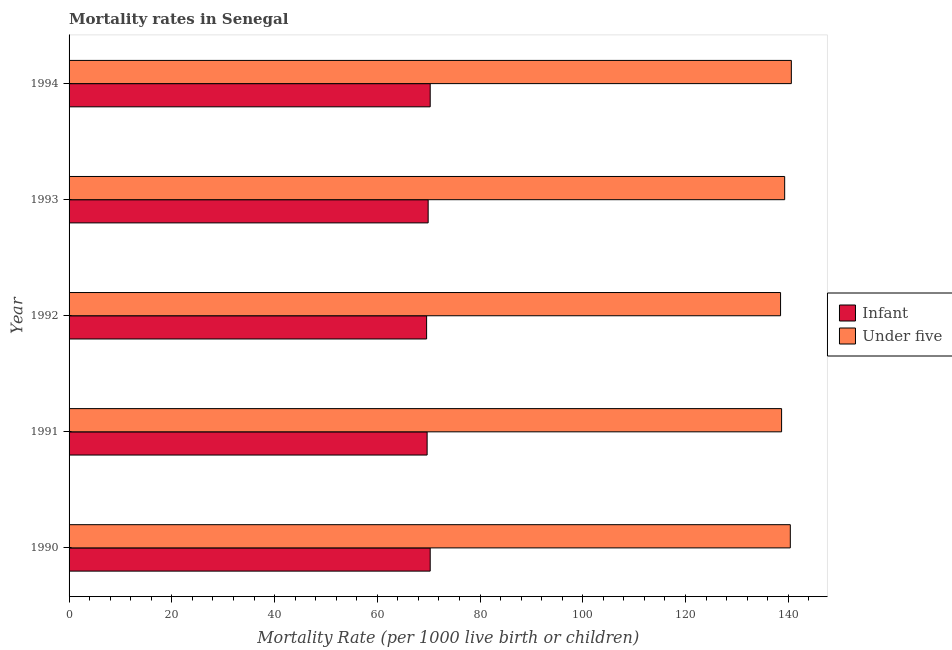How many groups of bars are there?
Give a very brief answer. 5. Are the number of bars per tick equal to the number of legend labels?
Offer a terse response. Yes. What is the label of the 4th group of bars from the top?
Offer a terse response. 1991. What is the under-5 mortality rate in 1990?
Make the answer very short. 140.4. Across all years, what is the maximum infant mortality rate?
Offer a very short reply. 70.3. Across all years, what is the minimum infant mortality rate?
Your answer should be compact. 69.6. In which year was the under-5 mortality rate maximum?
Provide a succinct answer. 1994. What is the total infant mortality rate in the graph?
Offer a terse response. 349.8. What is the difference between the under-5 mortality rate in 1990 and that in 1994?
Make the answer very short. -0.2. What is the difference between the infant mortality rate in 1992 and the under-5 mortality rate in 1991?
Make the answer very short. -69.1. What is the average under-5 mortality rate per year?
Offer a terse response. 139.5. In the year 1993, what is the difference between the under-5 mortality rate and infant mortality rate?
Keep it short and to the point. 69.4. In how many years, is the under-5 mortality rate greater than 20 ?
Offer a very short reply. 5. What is the ratio of the under-5 mortality rate in 1990 to that in 1991?
Provide a succinct answer. 1.01. Is the difference between the under-5 mortality rate in 1990 and 1991 greater than the difference between the infant mortality rate in 1990 and 1991?
Keep it short and to the point. Yes. What is the difference between the highest and the second highest infant mortality rate?
Keep it short and to the point. 0. What does the 2nd bar from the top in 1992 represents?
Make the answer very short. Infant. What does the 2nd bar from the bottom in 1991 represents?
Offer a very short reply. Under five. Are all the bars in the graph horizontal?
Provide a short and direct response. Yes. How many years are there in the graph?
Offer a terse response. 5. Does the graph contain any zero values?
Your response must be concise. No. Does the graph contain grids?
Your answer should be very brief. No. How many legend labels are there?
Give a very brief answer. 2. How are the legend labels stacked?
Provide a short and direct response. Vertical. What is the title of the graph?
Your answer should be very brief. Mortality rates in Senegal. Does "Goods" appear as one of the legend labels in the graph?
Your answer should be very brief. No. What is the label or title of the X-axis?
Offer a terse response. Mortality Rate (per 1000 live birth or children). What is the Mortality Rate (per 1000 live birth or children) of Infant in 1990?
Give a very brief answer. 70.3. What is the Mortality Rate (per 1000 live birth or children) in Under five in 1990?
Your answer should be compact. 140.4. What is the Mortality Rate (per 1000 live birth or children) in Infant in 1991?
Your response must be concise. 69.7. What is the Mortality Rate (per 1000 live birth or children) of Under five in 1991?
Your answer should be compact. 138.7. What is the Mortality Rate (per 1000 live birth or children) of Infant in 1992?
Keep it short and to the point. 69.6. What is the Mortality Rate (per 1000 live birth or children) of Under five in 1992?
Ensure brevity in your answer.  138.5. What is the Mortality Rate (per 1000 live birth or children) of Infant in 1993?
Offer a very short reply. 69.9. What is the Mortality Rate (per 1000 live birth or children) in Under five in 1993?
Ensure brevity in your answer.  139.3. What is the Mortality Rate (per 1000 live birth or children) of Infant in 1994?
Your answer should be compact. 70.3. What is the Mortality Rate (per 1000 live birth or children) of Under five in 1994?
Offer a very short reply. 140.6. Across all years, what is the maximum Mortality Rate (per 1000 live birth or children) of Infant?
Offer a terse response. 70.3. Across all years, what is the maximum Mortality Rate (per 1000 live birth or children) of Under five?
Your response must be concise. 140.6. Across all years, what is the minimum Mortality Rate (per 1000 live birth or children) of Infant?
Offer a terse response. 69.6. Across all years, what is the minimum Mortality Rate (per 1000 live birth or children) of Under five?
Give a very brief answer. 138.5. What is the total Mortality Rate (per 1000 live birth or children) in Infant in the graph?
Your response must be concise. 349.8. What is the total Mortality Rate (per 1000 live birth or children) of Under five in the graph?
Offer a terse response. 697.5. What is the difference between the Mortality Rate (per 1000 live birth or children) in Under five in 1990 and that in 1991?
Your answer should be very brief. 1.7. What is the difference between the Mortality Rate (per 1000 live birth or children) in Infant in 1990 and that in 1992?
Provide a succinct answer. 0.7. What is the difference between the Mortality Rate (per 1000 live birth or children) of Under five in 1990 and that in 1992?
Provide a short and direct response. 1.9. What is the difference between the Mortality Rate (per 1000 live birth or children) in Under five in 1990 and that in 1993?
Your answer should be very brief. 1.1. What is the difference between the Mortality Rate (per 1000 live birth or children) of Infant in 1990 and that in 1994?
Ensure brevity in your answer.  0. What is the difference between the Mortality Rate (per 1000 live birth or children) of Infant in 1991 and that in 1994?
Provide a short and direct response. -0.6. What is the difference between the Mortality Rate (per 1000 live birth or children) of Under five in 1991 and that in 1994?
Make the answer very short. -1.9. What is the difference between the Mortality Rate (per 1000 live birth or children) in Infant in 1992 and that in 1993?
Provide a short and direct response. -0.3. What is the difference between the Mortality Rate (per 1000 live birth or children) in Under five in 1992 and that in 1993?
Offer a terse response. -0.8. What is the difference between the Mortality Rate (per 1000 live birth or children) in Infant in 1992 and that in 1994?
Your response must be concise. -0.7. What is the difference between the Mortality Rate (per 1000 live birth or children) of Under five in 1992 and that in 1994?
Offer a very short reply. -2.1. What is the difference between the Mortality Rate (per 1000 live birth or children) of Infant in 1993 and that in 1994?
Your answer should be compact. -0.4. What is the difference between the Mortality Rate (per 1000 live birth or children) of Under five in 1993 and that in 1994?
Give a very brief answer. -1.3. What is the difference between the Mortality Rate (per 1000 live birth or children) of Infant in 1990 and the Mortality Rate (per 1000 live birth or children) of Under five in 1991?
Ensure brevity in your answer.  -68.4. What is the difference between the Mortality Rate (per 1000 live birth or children) of Infant in 1990 and the Mortality Rate (per 1000 live birth or children) of Under five in 1992?
Offer a terse response. -68.2. What is the difference between the Mortality Rate (per 1000 live birth or children) of Infant in 1990 and the Mortality Rate (per 1000 live birth or children) of Under five in 1993?
Your answer should be compact. -69. What is the difference between the Mortality Rate (per 1000 live birth or children) of Infant in 1990 and the Mortality Rate (per 1000 live birth or children) of Under five in 1994?
Your answer should be very brief. -70.3. What is the difference between the Mortality Rate (per 1000 live birth or children) in Infant in 1991 and the Mortality Rate (per 1000 live birth or children) in Under five in 1992?
Offer a very short reply. -68.8. What is the difference between the Mortality Rate (per 1000 live birth or children) of Infant in 1991 and the Mortality Rate (per 1000 live birth or children) of Under five in 1993?
Your answer should be very brief. -69.6. What is the difference between the Mortality Rate (per 1000 live birth or children) of Infant in 1991 and the Mortality Rate (per 1000 live birth or children) of Under five in 1994?
Keep it short and to the point. -70.9. What is the difference between the Mortality Rate (per 1000 live birth or children) of Infant in 1992 and the Mortality Rate (per 1000 live birth or children) of Under five in 1993?
Your answer should be very brief. -69.7. What is the difference between the Mortality Rate (per 1000 live birth or children) of Infant in 1992 and the Mortality Rate (per 1000 live birth or children) of Under five in 1994?
Ensure brevity in your answer.  -71. What is the difference between the Mortality Rate (per 1000 live birth or children) of Infant in 1993 and the Mortality Rate (per 1000 live birth or children) of Under five in 1994?
Make the answer very short. -70.7. What is the average Mortality Rate (per 1000 live birth or children) in Infant per year?
Keep it short and to the point. 69.96. What is the average Mortality Rate (per 1000 live birth or children) in Under five per year?
Keep it short and to the point. 139.5. In the year 1990, what is the difference between the Mortality Rate (per 1000 live birth or children) of Infant and Mortality Rate (per 1000 live birth or children) of Under five?
Offer a terse response. -70.1. In the year 1991, what is the difference between the Mortality Rate (per 1000 live birth or children) of Infant and Mortality Rate (per 1000 live birth or children) of Under five?
Provide a short and direct response. -69. In the year 1992, what is the difference between the Mortality Rate (per 1000 live birth or children) of Infant and Mortality Rate (per 1000 live birth or children) of Under five?
Provide a succinct answer. -68.9. In the year 1993, what is the difference between the Mortality Rate (per 1000 live birth or children) of Infant and Mortality Rate (per 1000 live birth or children) of Under five?
Offer a very short reply. -69.4. In the year 1994, what is the difference between the Mortality Rate (per 1000 live birth or children) in Infant and Mortality Rate (per 1000 live birth or children) in Under five?
Offer a terse response. -70.3. What is the ratio of the Mortality Rate (per 1000 live birth or children) in Infant in 1990 to that in 1991?
Give a very brief answer. 1.01. What is the ratio of the Mortality Rate (per 1000 live birth or children) in Under five in 1990 to that in 1991?
Offer a terse response. 1.01. What is the ratio of the Mortality Rate (per 1000 live birth or children) in Under five in 1990 to that in 1992?
Your response must be concise. 1.01. What is the ratio of the Mortality Rate (per 1000 live birth or children) of Under five in 1990 to that in 1993?
Offer a terse response. 1.01. What is the ratio of the Mortality Rate (per 1000 live birth or children) of Infant in 1990 to that in 1994?
Give a very brief answer. 1. What is the ratio of the Mortality Rate (per 1000 live birth or children) in Under five in 1990 to that in 1994?
Offer a very short reply. 1. What is the ratio of the Mortality Rate (per 1000 live birth or children) of Infant in 1991 to that in 1994?
Offer a terse response. 0.99. What is the ratio of the Mortality Rate (per 1000 live birth or children) in Under five in 1991 to that in 1994?
Offer a very short reply. 0.99. What is the ratio of the Mortality Rate (per 1000 live birth or children) of Under five in 1992 to that in 1993?
Keep it short and to the point. 0.99. What is the ratio of the Mortality Rate (per 1000 live birth or children) in Infant in 1992 to that in 1994?
Your answer should be very brief. 0.99. What is the ratio of the Mortality Rate (per 1000 live birth or children) of Under five in 1992 to that in 1994?
Provide a succinct answer. 0.99. What is the ratio of the Mortality Rate (per 1000 live birth or children) of Infant in 1993 to that in 1994?
Keep it short and to the point. 0.99. What is the ratio of the Mortality Rate (per 1000 live birth or children) of Under five in 1993 to that in 1994?
Your answer should be very brief. 0.99. What is the difference between the highest and the second highest Mortality Rate (per 1000 live birth or children) in Infant?
Offer a very short reply. 0. What is the difference between the highest and the lowest Mortality Rate (per 1000 live birth or children) of Under five?
Provide a succinct answer. 2.1. 